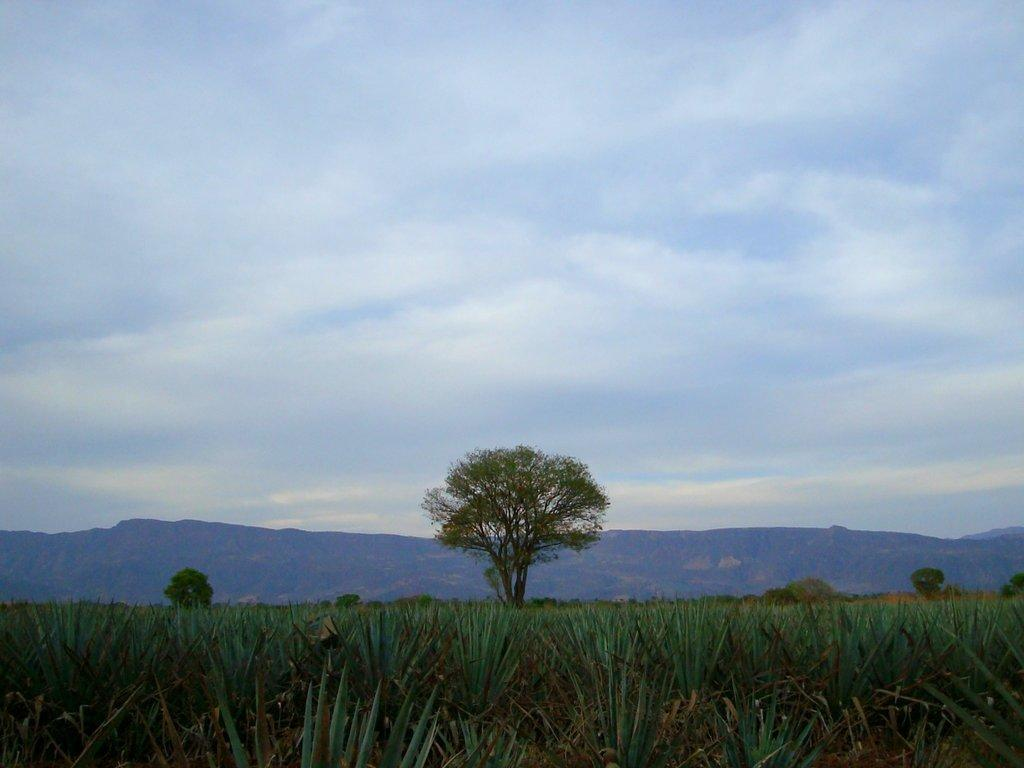What objects are on the ground in the image? There are planets on the ground in the image. What can be seen in the background of the image? There are trees, mountains, and clouds in the sky in the background of the image. What type of loaf is being discussed by the planets in the image? There is no loaf present in the image, nor is there any discussion taking place among the planets. 